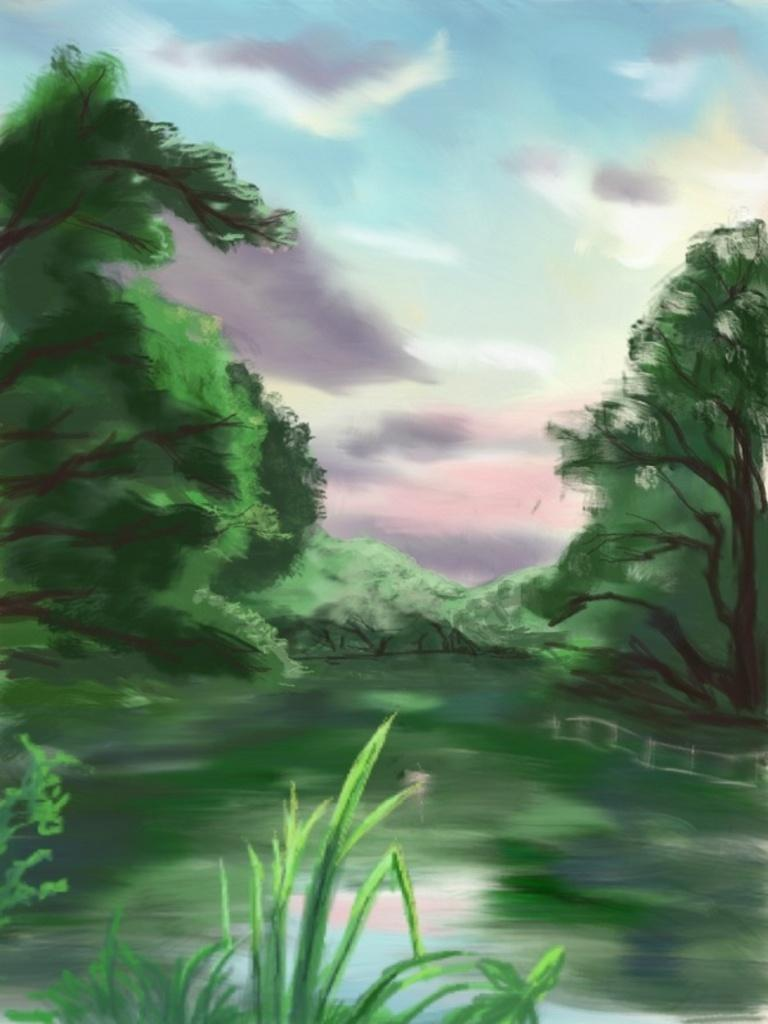What type of artwork is the image? The image is a painting. What is the main subject depicted in the painting? The painting depicts water and trees. What type of riddle can be found hidden within the painting? There is no riddle hidden within the painting; it is a visual representation of water and trees. What emotion is the painting expressing? The painting is not expressing any specific emotion, as it is a visual representation of water and trees. 